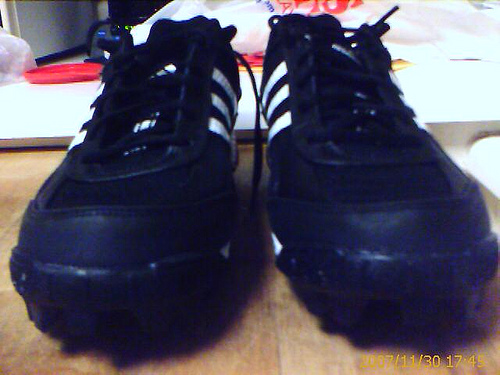<image>
Can you confirm if the shoelace is on the shoe? No. The shoelace is not positioned on the shoe. They may be near each other, but the shoelace is not supported by or resting on top of the shoe. Where is the shoe in relation to the shoe? Is it to the left of the shoe? Yes. From this viewpoint, the shoe is positioned to the left side relative to the shoe. 